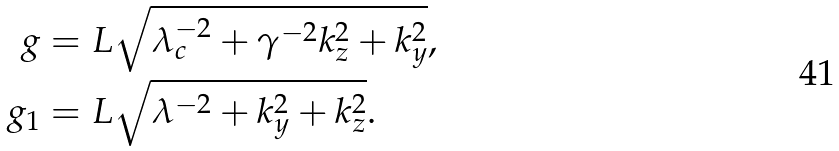<formula> <loc_0><loc_0><loc_500><loc_500>g & = L \sqrt { \lambda _ { c } ^ { - 2 } + \gamma ^ { - 2 } k _ { z } ^ { 2 } + k _ { y } ^ { 2 } } , \\ g _ { 1 } & = L \sqrt { \lambda ^ { - 2 } + k _ { y } ^ { 2 } + k _ { z } ^ { 2 } } .</formula> 